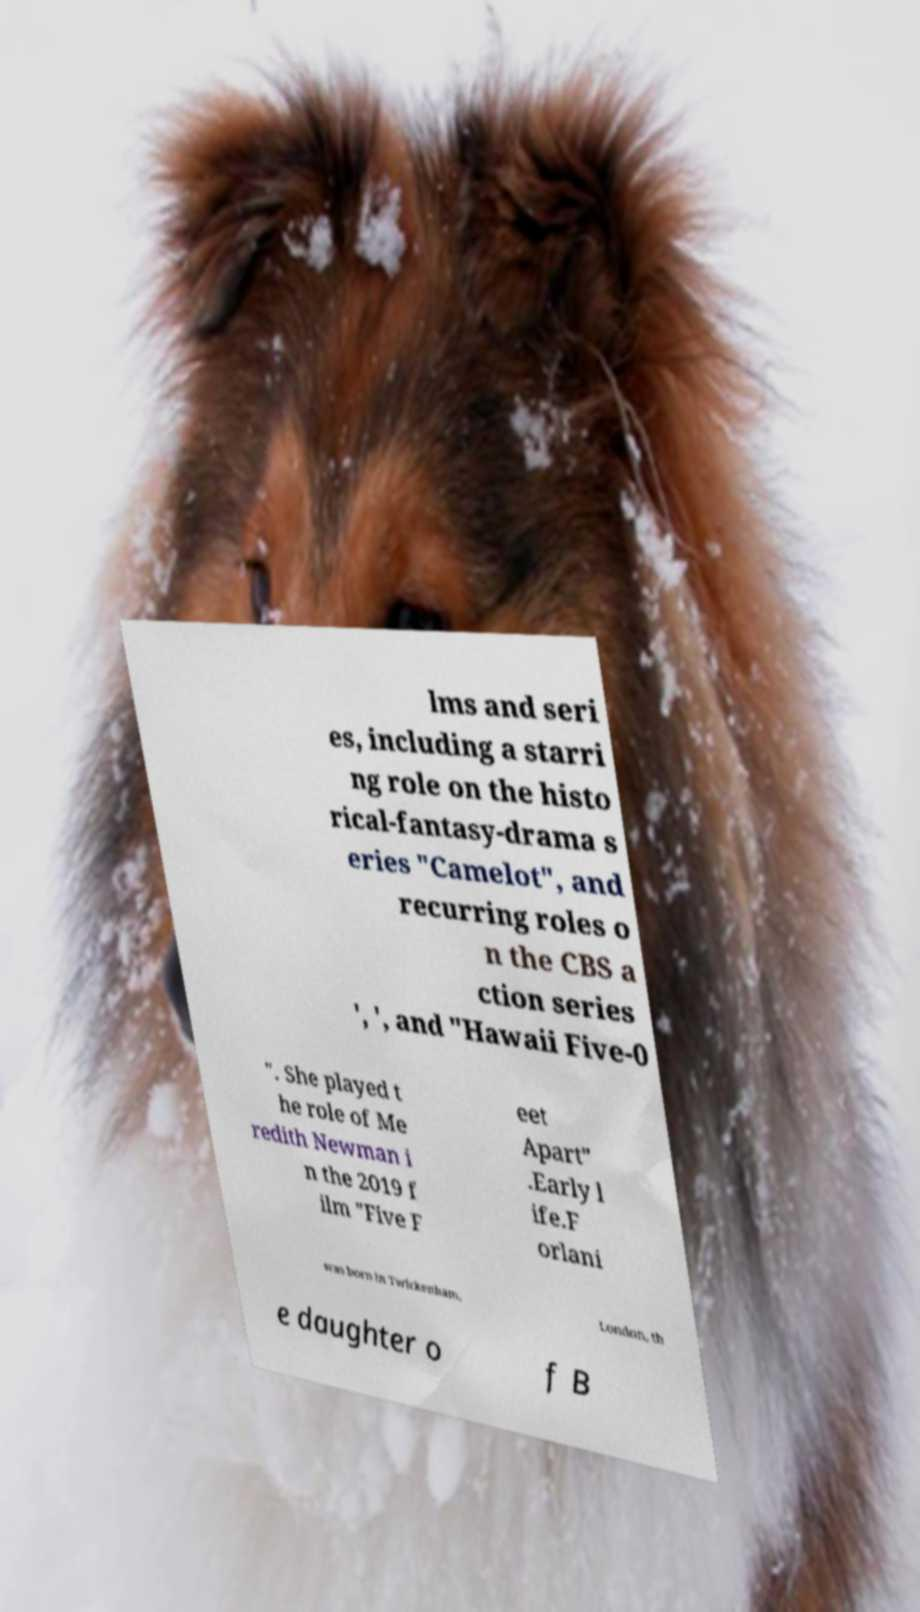There's text embedded in this image that I need extracted. Can you transcribe it verbatim? lms and seri es, including a starri ng role on the histo rical-fantasy-drama s eries "Camelot", and recurring roles o n the CBS a ction series ', ', and "Hawaii Five-0 ". She played t he role of Me redith Newman i n the 2019 f ilm "Five F eet Apart" .Early l ife.F orlani was born in Twickenham, London, th e daughter o f B 